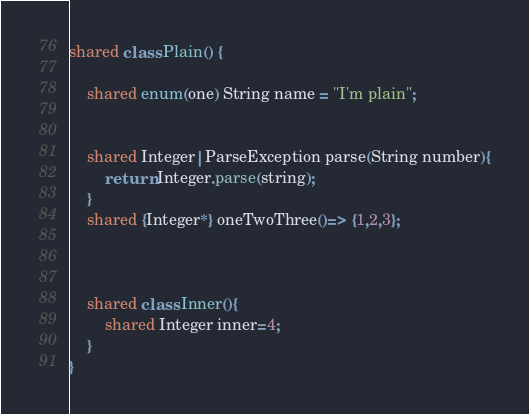Convert code to text. <code><loc_0><loc_0><loc_500><loc_500><_Ceylon_>shared class Plain() {
	
	shared enum(one) String name = "I'm plain";
	
	
	shared Integer|ParseException parse(String number){
		return Integer.parse(string);
	}
	shared {Integer*} oneTwoThree()=> {1,2,3};
	
	
	
	shared class Inner(){
		shared Integer inner=4;
	}
}</code> 